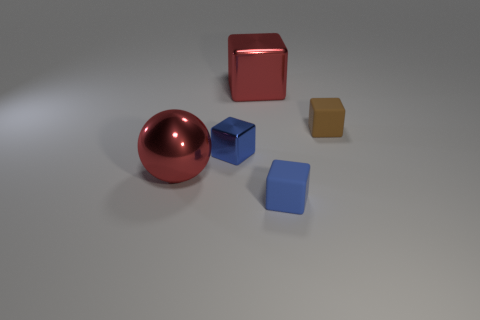Subtract all yellow cylinders. How many blue cubes are left? 2 Add 5 blue rubber objects. How many objects exist? 10 Subtract all cyan cubes. Subtract all red cylinders. How many cubes are left? 4 Subtract all blocks. How many objects are left? 1 Add 2 metallic things. How many metallic things exist? 5 Subtract 0 green spheres. How many objects are left? 5 Subtract all small blue shiny objects. Subtract all small brown rubber things. How many objects are left? 3 Add 4 big metallic objects. How many big metallic objects are left? 6 